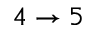<formula> <loc_0><loc_0><loc_500><loc_500>4 \rightarrow 5</formula> 